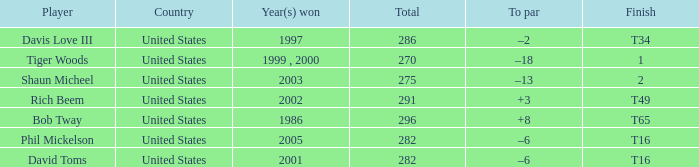Could you parse the entire table as a dict? {'header': ['Player', 'Country', 'Year(s) won', 'Total', 'To par', 'Finish'], 'rows': [['Davis Love III', 'United States', '1997', '286', '–2', 'T34'], ['Tiger Woods', 'United States', '1999 , 2000', '270', '–18', '1'], ['Shaun Micheel', 'United States', '2003', '275', '–13', '2'], ['Rich Beem', 'United States', '2002', '291', '+3', 'T49'], ['Bob Tway', 'United States', '1986', '296', '+8', 'T65'], ['Phil Mickelson', 'United States', '2005', '282', '–6', 'T16'], ['David Toms', 'United States', '2001', '282', '–6', 'T16']]} What is the to par number of the person who won in 2003? –13. 